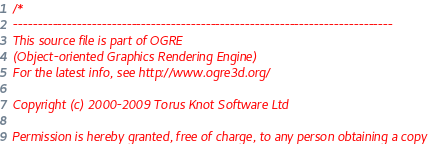<code> <loc_0><loc_0><loc_500><loc_500><_C++_>/*
-----------------------------------------------------------------------------
This source file is part of OGRE
(Object-oriented Graphics Rendering Engine)
For the latest info, see http://www.ogre3d.org/

Copyright (c) 2000-2009 Torus Knot Software Ltd

Permission is hereby granted, free of charge, to any person obtaining a copy</code> 